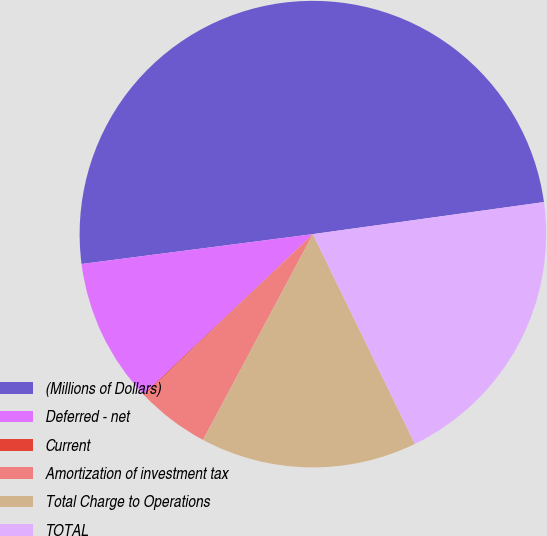<chart> <loc_0><loc_0><loc_500><loc_500><pie_chart><fcel>(Millions of Dollars)<fcel>Deferred - net<fcel>Current<fcel>Amortization of investment tax<fcel>Total Charge to Operations<fcel>TOTAL<nl><fcel>49.85%<fcel>10.03%<fcel>0.07%<fcel>5.05%<fcel>15.01%<fcel>19.99%<nl></chart> 